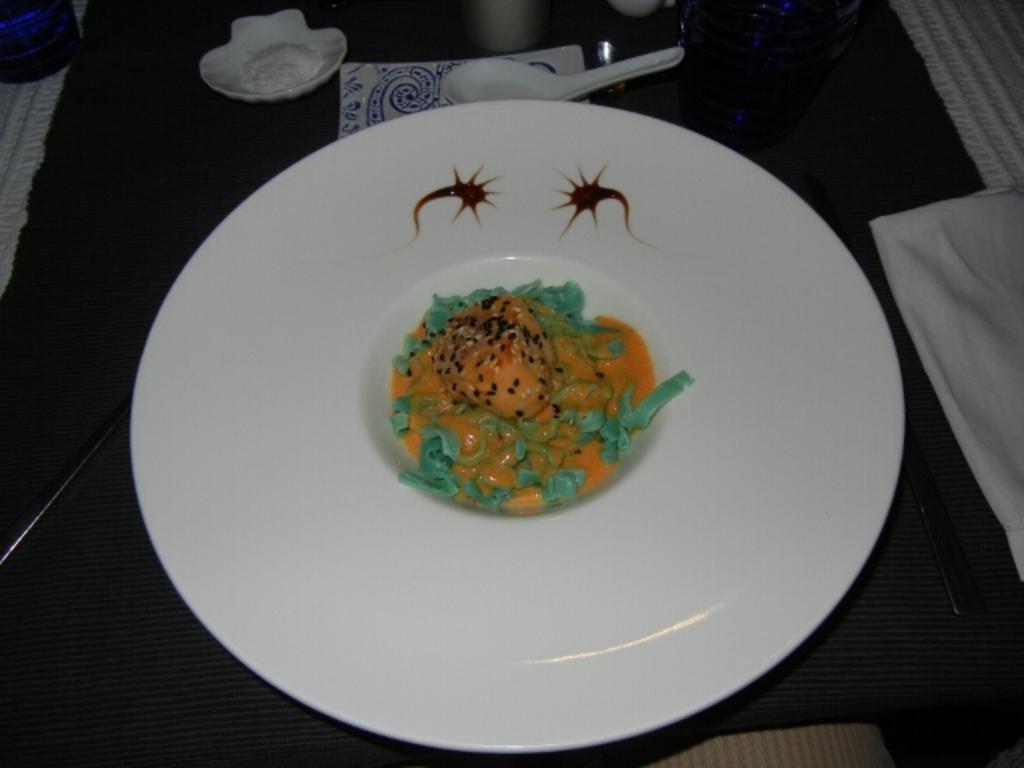Can you describe this image briefly? In this image we can see a white plate with the food item and we can see a spoon and some other objects on the table. 